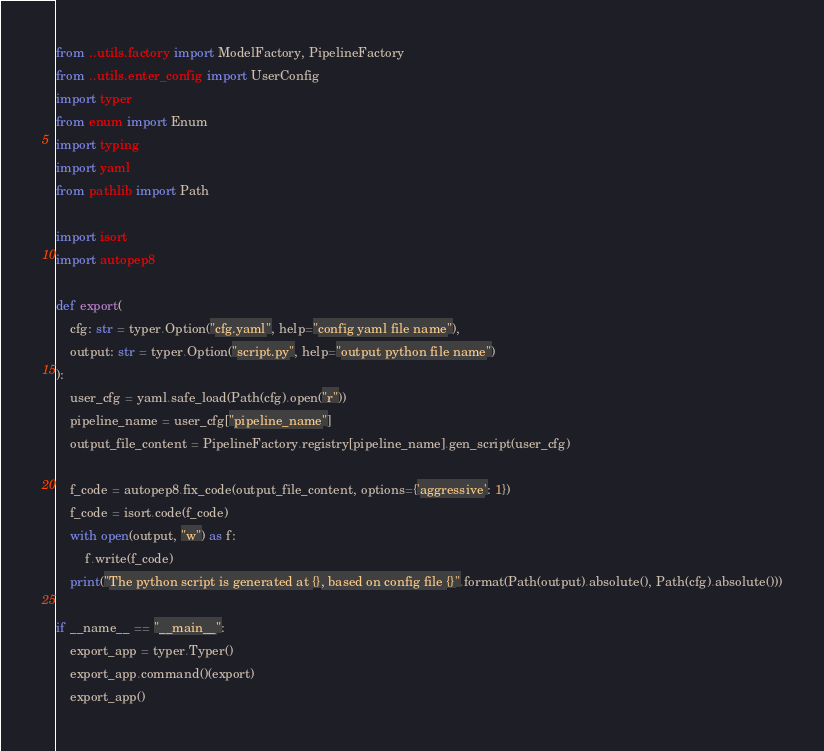<code> <loc_0><loc_0><loc_500><loc_500><_Python_>from ..utils.factory import ModelFactory, PipelineFactory
from ..utils.enter_config import UserConfig
import typer
from enum import Enum
import typing
import yaml
from pathlib import Path

import isort
import autopep8

def export(
    cfg: str = typer.Option("cfg.yaml", help="config yaml file name"),
    output: str = typer.Option("script.py", help="output python file name")
):
    user_cfg = yaml.safe_load(Path(cfg).open("r"))
    pipeline_name = user_cfg["pipeline_name"]
    output_file_content = PipelineFactory.registry[pipeline_name].gen_script(user_cfg)

    f_code = autopep8.fix_code(output_file_content, options={'aggressive': 1})
    f_code = isort.code(f_code)
    with open(output, "w") as f:
        f.write(f_code)
    print("The python script is generated at {}, based on config file {}".format(Path(output).absolute(), Path(cfg).absolute()))

if __name__ == "__main__":
    export_app = typer.Typer()
    export_app.command()(export)
    export_app()</code> 